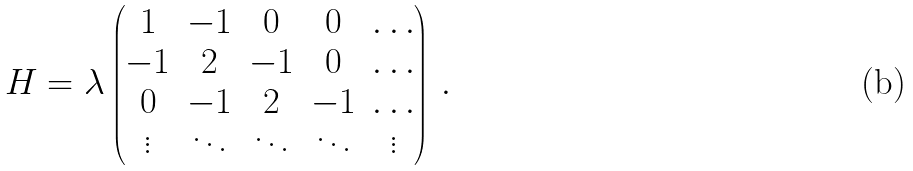Convert formula to latex. <formula><loc_0><loc_0><loc_500><loc_500>H = \lambda \begin{pmatrix} 1 & - 1 & 0 & 0 & \dots \\ - 1 & 2 & - 1 & 0 & \dots \\ 0 & - 1 & 2 & - 1 & \dots \\ \vdots & \ddots & \ddots & \ddots & \vdots \end{pmatrix} \, .</formula> 